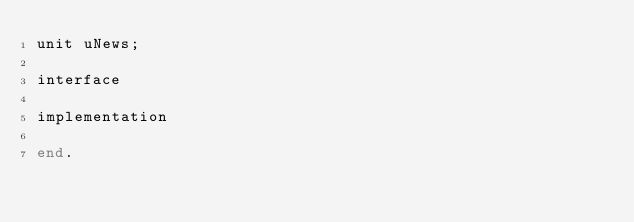Convert code to text. <code><loc_0><loc_0><loc_500><loc_500><_Pascal_>unit uNews;

interface 

implementation

end.
</code> 